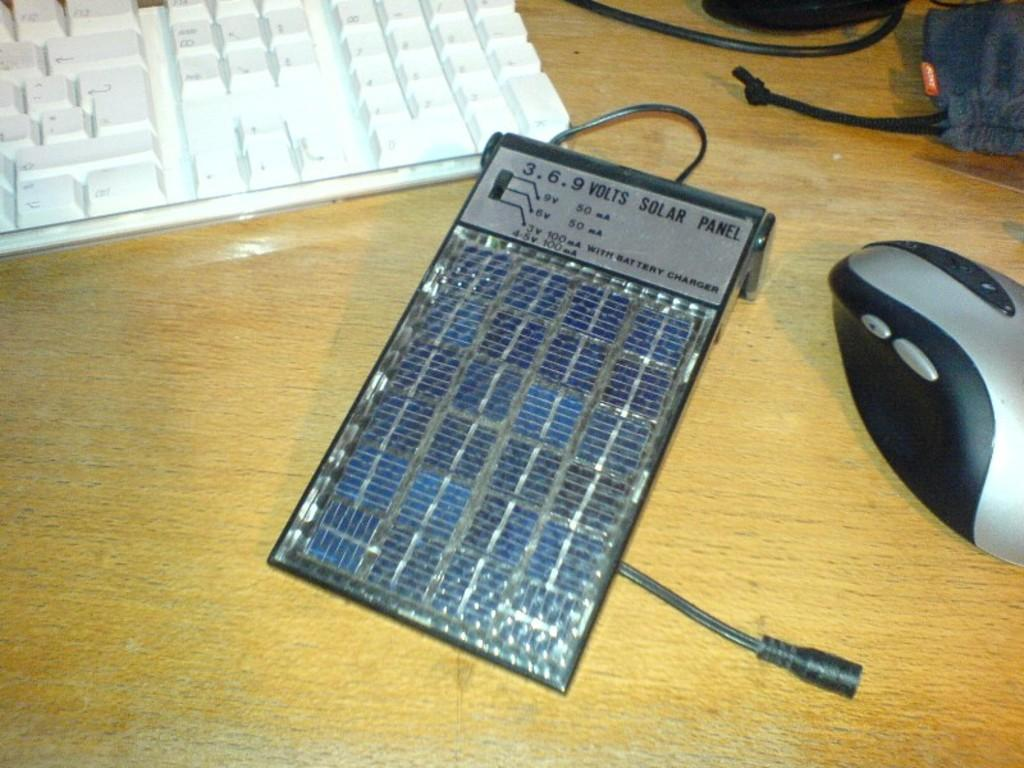What electronic device is visible in the image? There is a keyboard in the image. What is another object related to the keyboard that is also visible? There is a mouse in the image. What type of renewable energy source is present in the image? There is a solar panel in the image. What can be used to carry or store items in the image? There is a pouch in the image. On what surface are the objects placed in the image? The objects are placed on a wooden platform. What type of debt is being discussed in the image? There is no mention of debt in the image; it features a keyboard, a mouse, a solar panel, a pouch, and a wooden platform. Can you tell me how many cushions are present in the image? There are no cushions present in the image. 